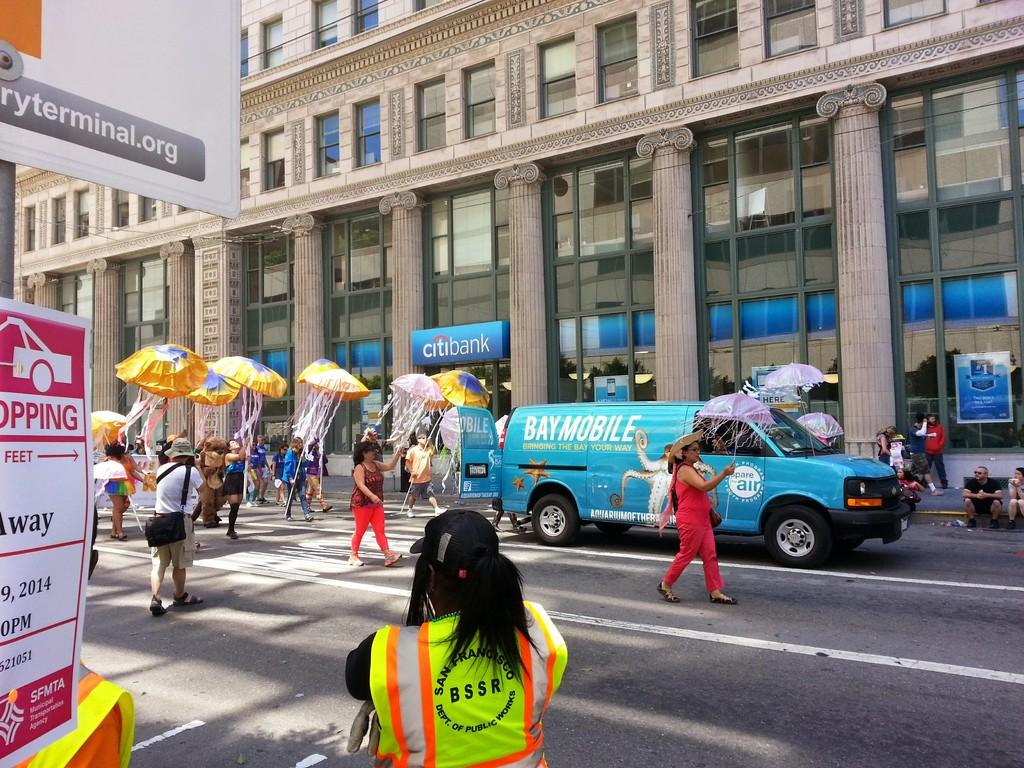<image>
Share a concise interpretation of the image provided. A lady with a yellow high vis vest on is from San Francisco Dept of public works. 